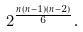<formula> <loc_0><loc_0><loc_500><loc_500>2 ^ { \frac { n ( n - 1 ) ( n - 2 ) } { 6 } } .</formula> 